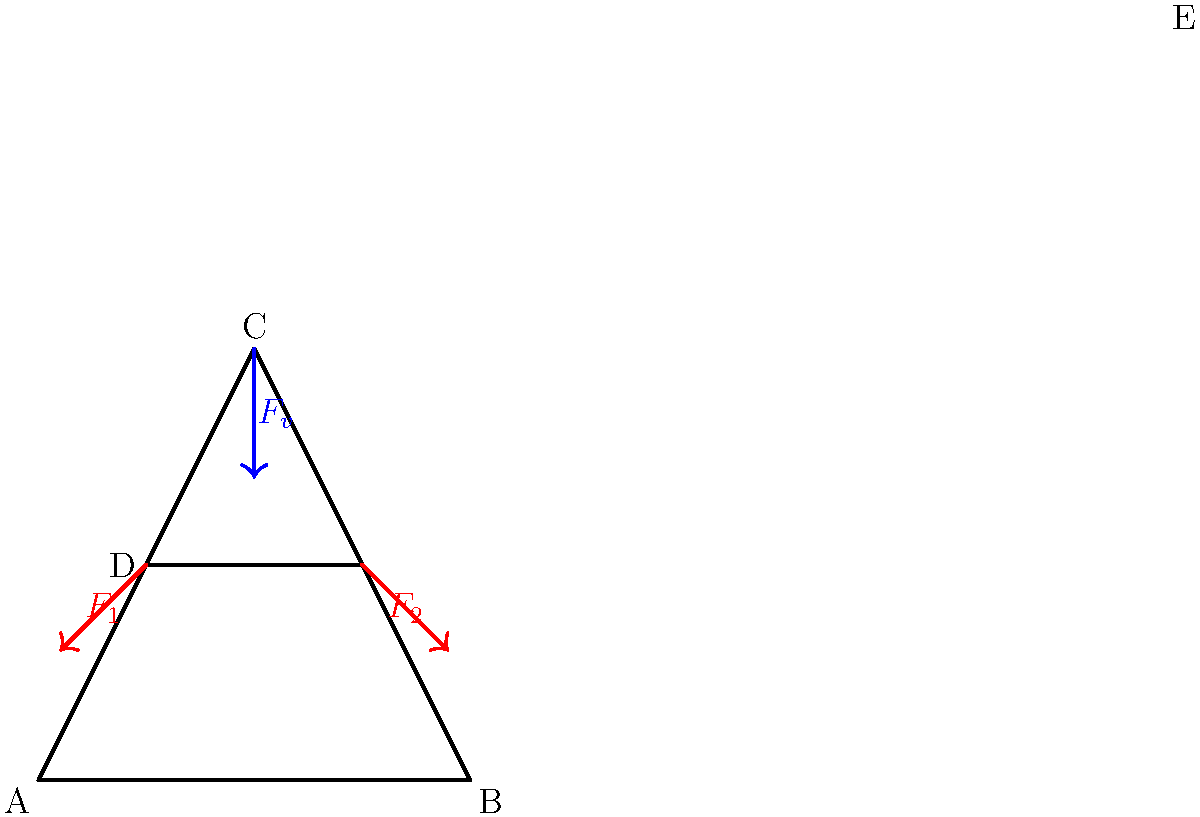In the force diagram of a drilling rig's derrick structure shown above, the vertical force $F_v$ at point C represents the weight of the drill string. Two tension forces $F_1$ and $F_2$ act on points D and E respectively. If $F_v = 1000 \text{ kN}$, $\angle ACD = \angle BCE = 60^\circ$, and the structure is symmetrical, calculate the magnitude of $F_1$ and $F_2$ to maintain equilibrium. To solve this problem, we'll follow these steps:

1) First, we recognize that the structure is symmetrical, so $F_1 = F_2$.

2) We can treat this as a problem of a single force ($F_v$) balanced by two equal forces ($F_1$ and $F_2$).

3) The vertical components of $F_1$ and $F_2$ must sum to equal $F_v$ for vertical equilibrium:

   $F_v = F_1 \sin 60^\circ + F_2 \sin 60^\circ = 2F_1 \sin 60^\circ$

4) We know that $\sin 60^\circ = \frac{\sqrt{3}}{2}$, so:

   $1000 \text{ kN} = 2F_1 \cdot \frac{\sqrt{3}}{2}$

5) Solving for $F_1$:

   $F_1 = \frac{1000}{\sqrt{3}} \text{ kN} \approx 577.35 \text{ kN}$

6) Since $F_1 = F_2$, both forces have this magnitude.
Answer: $F_1 = F_2 = \frac{1000}{\sqrt{3}} \text{ kN} \approx 577.35 \text{ kN}$ 